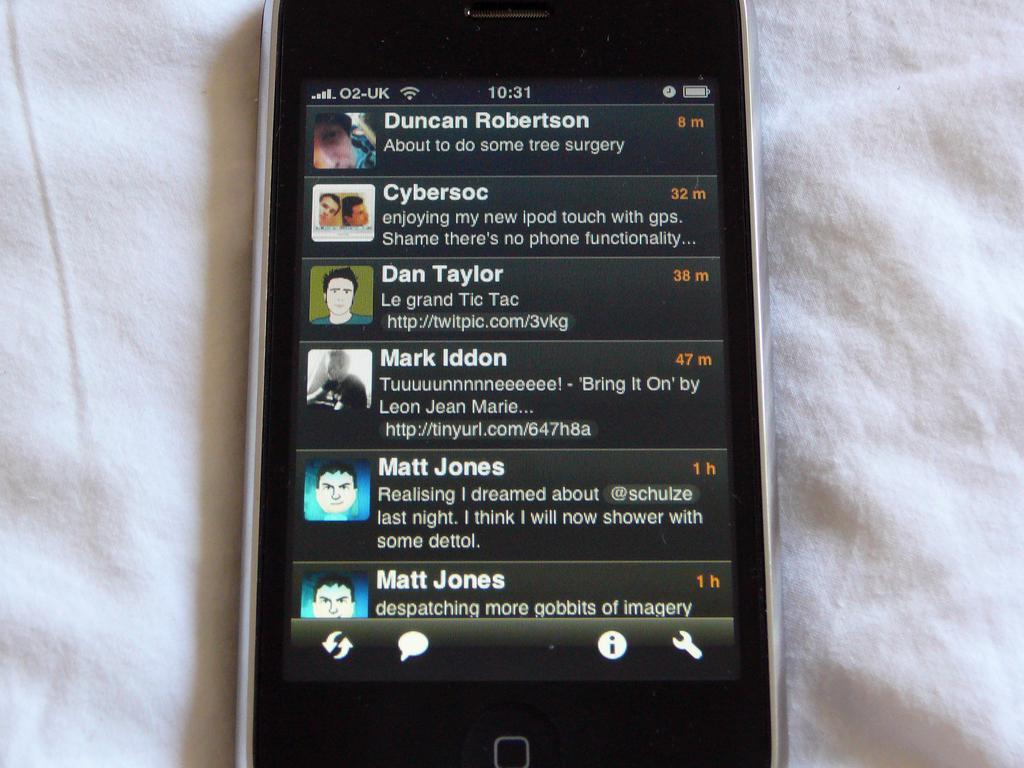Can you describe this image briefly? In this image there is a mobile, may be kept on white color cloth, on the screen, I can see a text, persons images, symbols, numbers. 